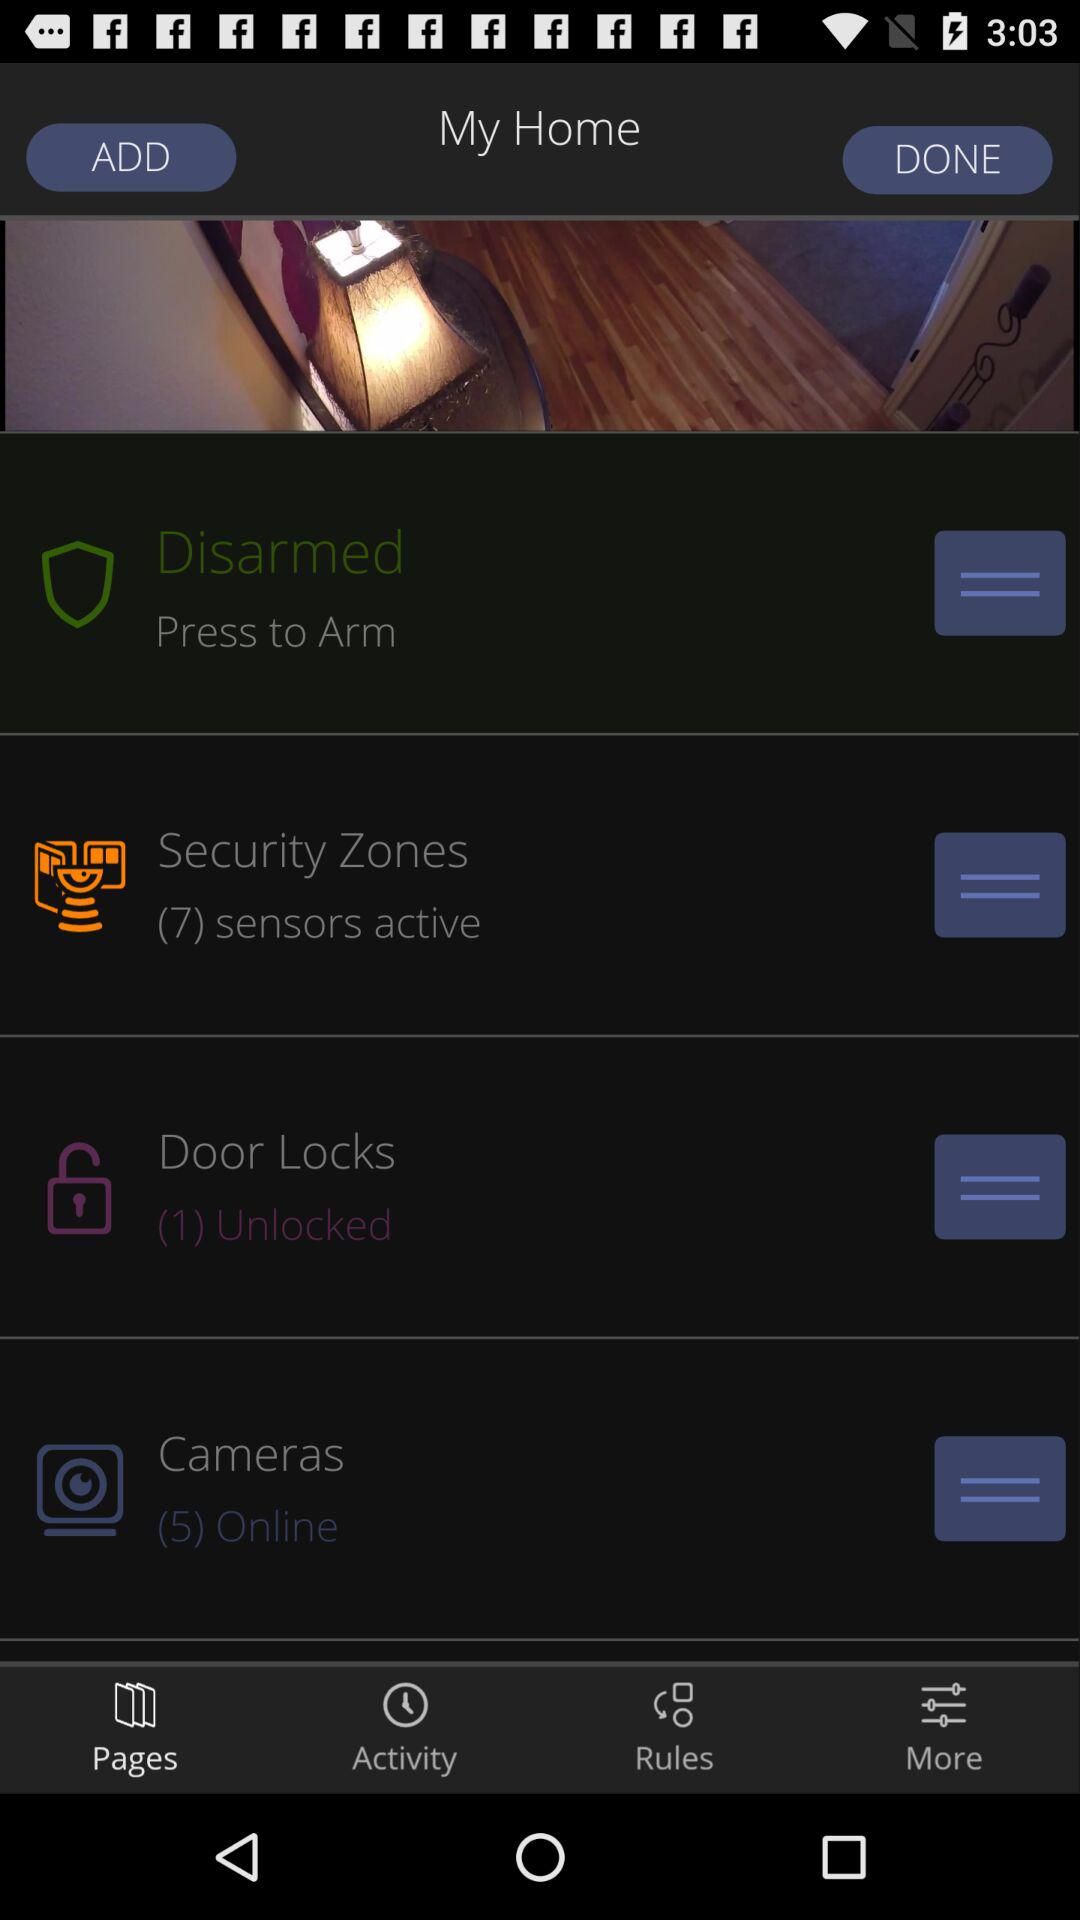How many doors are unlocked? The unlocked door is 1. 